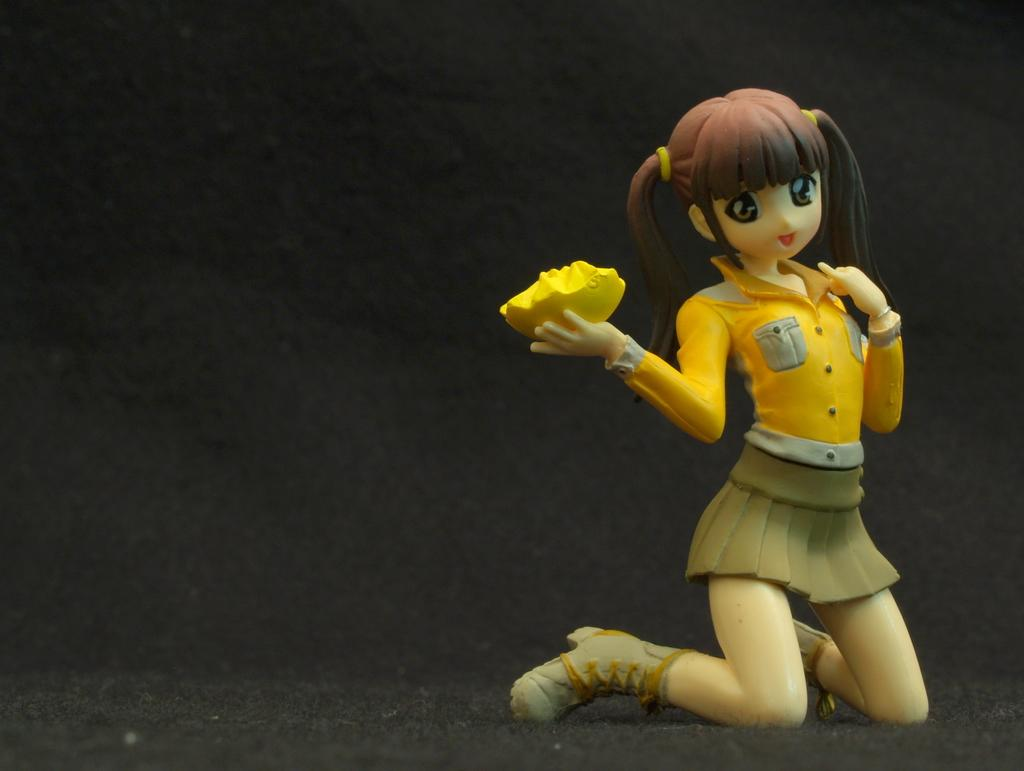What type of toy is on the right side of the image? There is a toy of a girl on the right side of the image. What color is the object in the image? There is a yellow color object in the image. How would you describe the background of the image? The background of the image is dark. Reasoning: Let' Let's think step by step in order to produce the conversation. We start by identifying the main subject on the right side of the image, which is the toy of a girl. Then, we describe the color of the object in the image, which is yellow. Finally, we mention the background of the image, which is dark. We ensure that each question can be answered definitively with the information given and avoid yes/no questions. Absurd Question/Answer: Can you tell me how many bones are visible in the image? There are no bones present in the image. What type of object is being rubbed in the image? There is no object being rubbed in the image. Can you tell me how many bones are visible in the image? There are no bones present in the image. What type of object is being rubbed in the image? There is no object being rubbed in the image. 